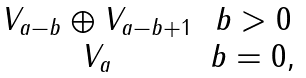Convert formula to latex. <formula><loc_0><loc_0><loc_500><loc_500>\begin{matrix} V _ { a - b } \oplus V _ { a - b + 1 } & b > 0 \\ V _ { a } & b = 0 , \end{matrix}</formula> 